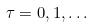Convert formula to latex. <formula><loc_0><loc_0><loc_500><loc_500>\tau = 0 , 1 , \dots</formula> 